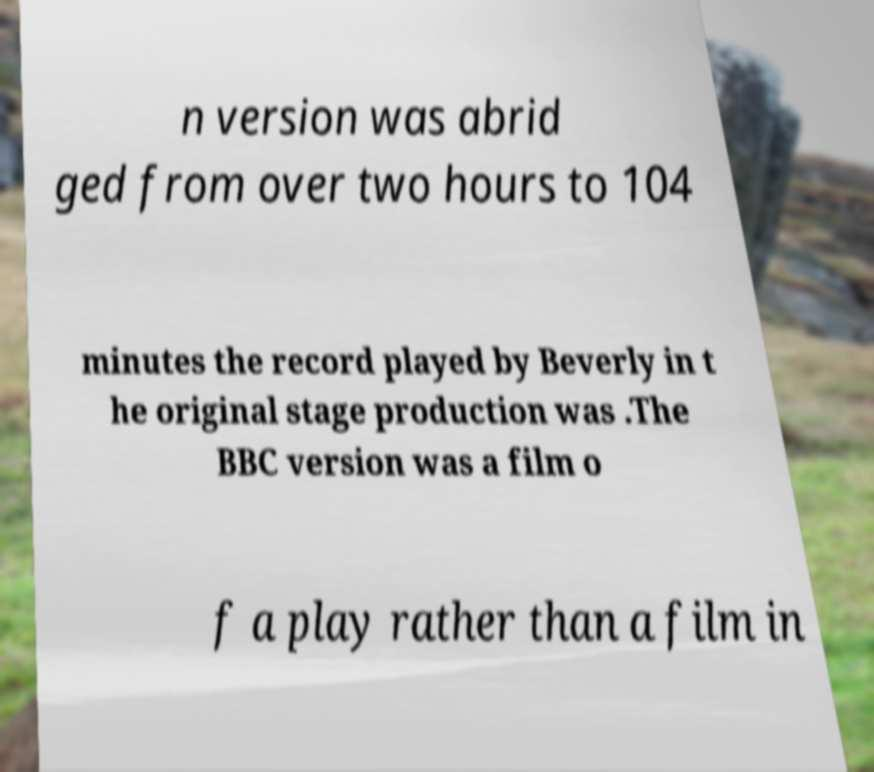Please identify and transcribe the text found in this image. n version was abrid ged from over two hours to 104 minutes the record played by Beverly in t he original stage production was .The BBC version was a film o f a play rather than a film in 